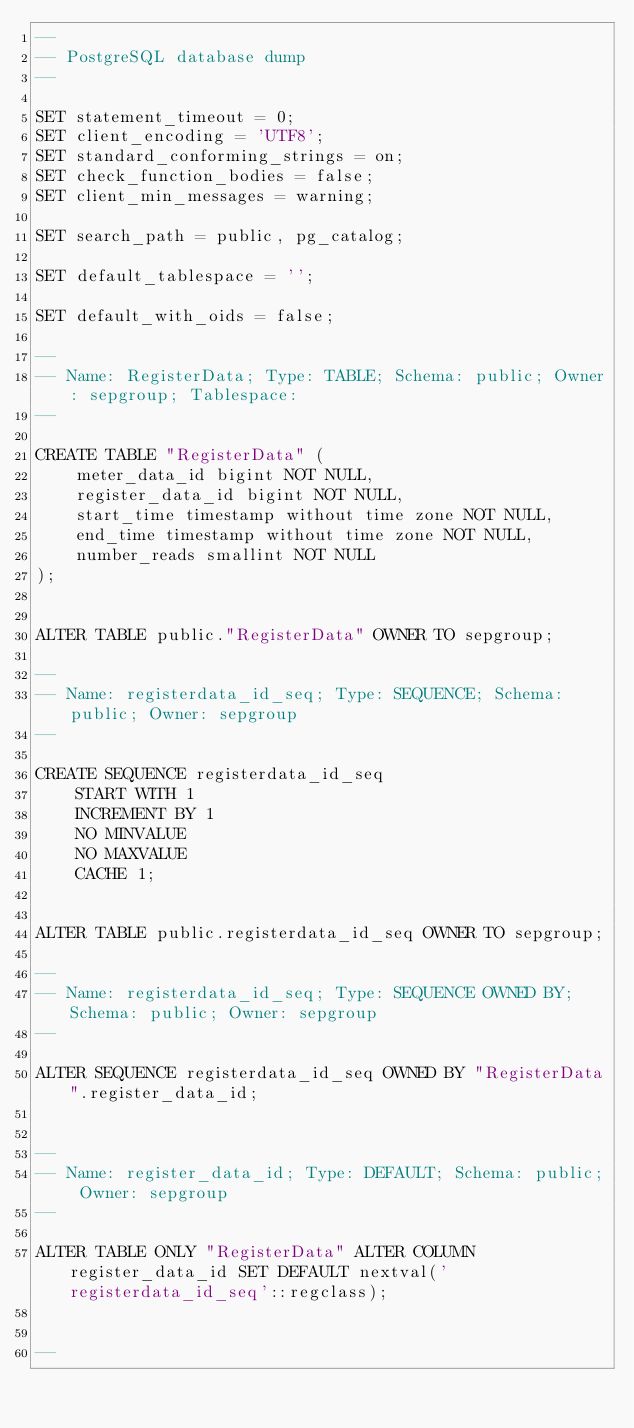<code> <loc_0><loc_0><loc_500><loc_500><_SQL_>--
-- PostgreSQL database dump
--

SET statement_timeout = 0;
SET client_encoding = 'UTF8';
SET standard_conforming_strings = on;
SET check_function_bodies = false;
SET client_min_messages = warning;

SET search_path = public, pg_catalog;

SET default_tablespace = '';

SET default_with_oids = false;

--
-- Name: RegisterData; Type: TABLE; Schema: public; Owner: sepgroup; Tablespace: 
--

CREATE TABLE "RegisterData" (
    meter_data_id bigint NOT NULL,
    register_data_id bigint NOT NULL,
    start_time timestamp without time zone NOT NULL,
    end_time timestamp without time zone NOT NULL,
    number_reads smallint NOT NULL
);


ALTER TABLE public."RegisterData" OWNER TO sepgroup;

--
-- Name: registerdata_id_seq; Type: SEQUENCE; Schema: public; Owner: sepgroup
--

CREATE SEQUENCE registerdata_id_seq
    START WITH 1
    INCREMENT BY 1
    NO MINVALUE
    NO MAXVALUE
    CACHE 1;


ALTER TABLE public.registerdata_id_seq OWNER TO sepgroup;

--
-- Name: registerdata_id_seq; Type: SEQUENCE OWNED BY; Schema: public; Owner: sepgroup
--

ALTER SEQUENCE registerdata_id_seq OWNED BY "RegisterData".register_data_id;


--
-- Name: register_data_id; Type: DEFAULT; Schema: public; Owner: sepgroup
--

ALTER TABLE ONLY "RegisterData" ALTER COLUMN register_data_id SET DEFAULT nextval('registerdata_id_seq'::regclass);


--</code> 